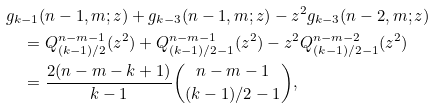<formula> <loc_0><loc_0><loc_500><loc_500>& g _ { k - 1 } ( n - 1 , m ; z ) + g _ { k - 3 } ( n - 1 , m ; z ) - z ^ { 2 } g _ { k - 3 } ( n - 2 , m ; z ) \\ & \quad = Q ^ { n - m - 1 } _ { ( k - 1 ) / 2 } ( z ^ { 2 } ) + Q ^ { n - m - 1 } _ { ( k - 1 ) / 2 - 1 } ( z ^ { 2 } ) - z ^ { 2 } Q ^ { n - m - 2 } _ { ( k - 1 ) / 2 - 1 } ( z ^ { 2 } ) \\ & \quad = \frac { 2 ( n - m - k + 1 ) } { k - 1 } \binom { n - m - 1 } { ( k - 1 ) / 2 - 1 } ,</formula> 